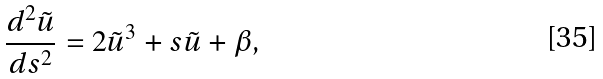<formula> <loc_0><loc_0><loc_500><loc_500>\frac { d ^ { 2 } \tilde { u } } { d s ^ { 2 } } = 2 \tilde { u } ^ { 3 } + s \tilde { u } + \beta ,</formula> 